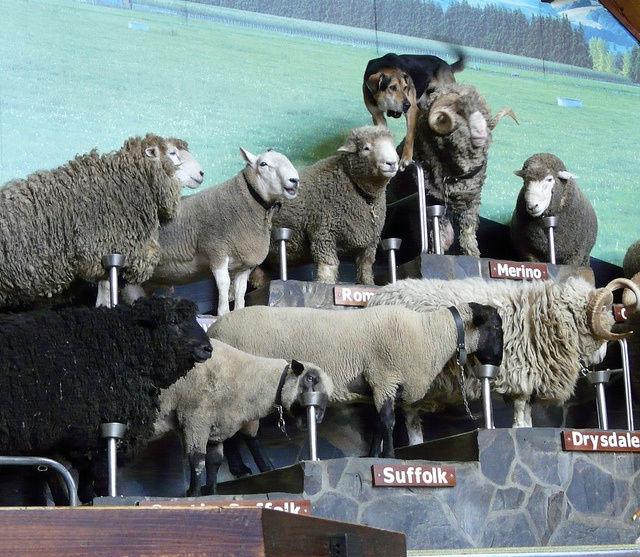Describe the objects in this image and their specific colors. I can see sheep in lightblue, black, and gray tones, sheep in lightblue, darkgray, black, gray, and lightgray tones, sheep in lightblue, darkgray, lightgray, gray, and black tones, sheep in lightblue, gray, black, and darkgray tones, and sheep in lightblue, gray, darkgray, lightgray, and black tones in this image. 